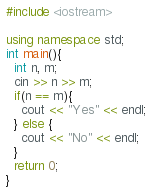<code> <loc_0><loc_0><loc_500><loc_500><_C++_>#include <iostream>

using namespace std;
int main(){
  int n, m;
  cin >> n >> m;
  if(n == m){
    cout << "Yes" << endl;
  } else {
    cout << "No" << endl;
  }
  return 0;
}

</code> 